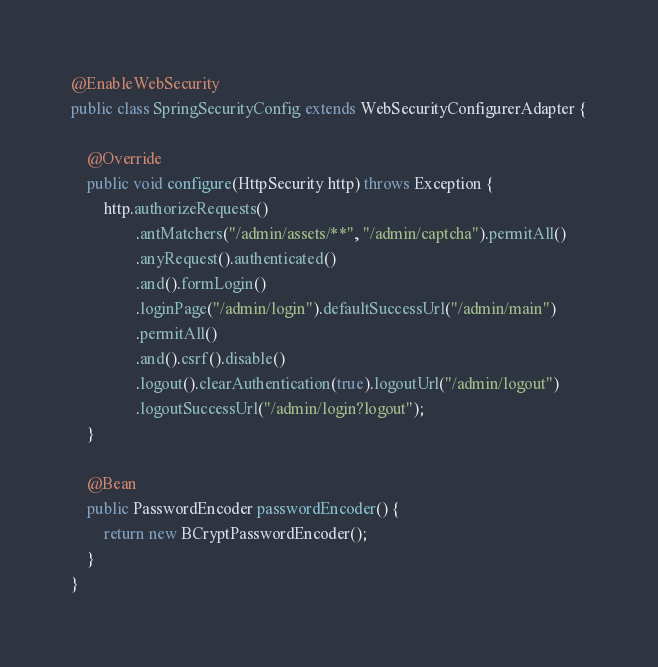Convert code to text. <code><loc_0><loc_0><loc_500><loc_500><_Java_>
@EnableWebSecurity
public class SpringSecurityConfig extends WebSecurityConfigurerAdapter {

    @Override
    public void configure(HttpSecurity http) throws Exception {
        http.authorizeRequests()
                .antMatchers("/admin/assets/**", "/admin/captcha").permitAll()
                .anyRequest().authenticated()
                .and().formLogin()
                .loginPage("/admin/login").defaultSuccessUrl("/admin/main")
                .permitAll()
                .and().csrf().disable()
                .logout().clearAuthentication(true).logoutUrl("/admin/logout")
                .logoutSuccessUrl("/admin/login?logout");
    }

    @Bean
    public PasswordEncoder passwordEncoder() {
        return new BCryptPasswordEncoder();
    }
}</code> 